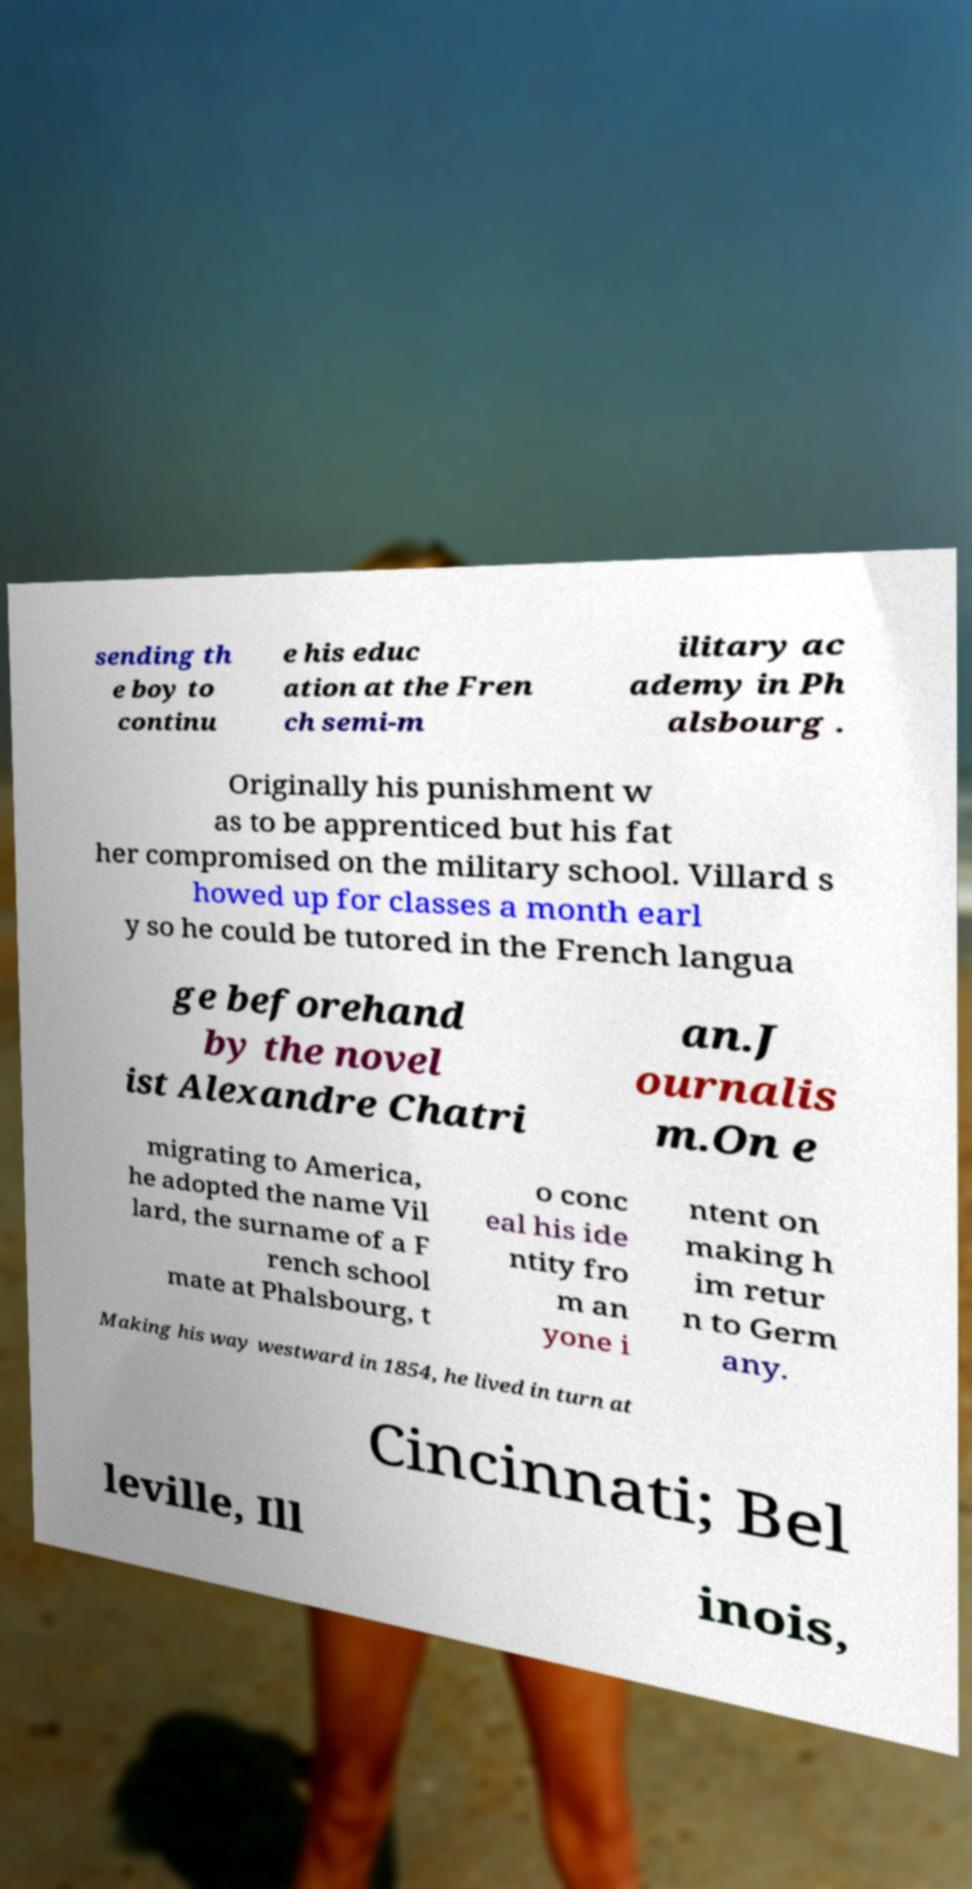Can you read and provide the text displayed in the image?This photo seems to have some interesting text. Can you extract and type it out for me? sending th e boy to continu e his educ ation at the Fren ch semi-m ilitary ac ademy in Ph alsbourg . Originally his punishment w as to be apprenticed but his fat her compromised on the military school. Villard s howed up for classes a month earl y so he could be tutored in the French langua ge beforehand by the novel ist Alexandre Chatri an.J ournalis m.On e migrating to America, he adopted the name Vil lard, the surname of a F rench school mate at Phalsbourg, t o conc eal his ide ntity fro m an yone i ntent on making h im retur n to Germ any. Making his way westward in 1854, he lived in turn at Cincinnati; Bel leville, Ill inois, 